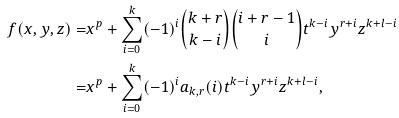Convert formula to latex. <formula><loc_0><loc_0><loc_500><loc_500>f ( x , y , z ) = & x ^ { p } + \sum _ { i = 0 } ^ { k } ( - 1 ) ^ { i } \binom { k + r } { k - i } \binom { i + r - 1 } { i } t ^ { k - i } y ^ { r + i } z ^ { k + l - i } \\ = & x ^ { p } + \sum _ { i = 0 } ^ { k } ( - 1 ) ^ { i } a _ { k , r } ( i ) t ^ { k - i } y ^ { r + i } z ^ { k + l - i } ,</formula> 